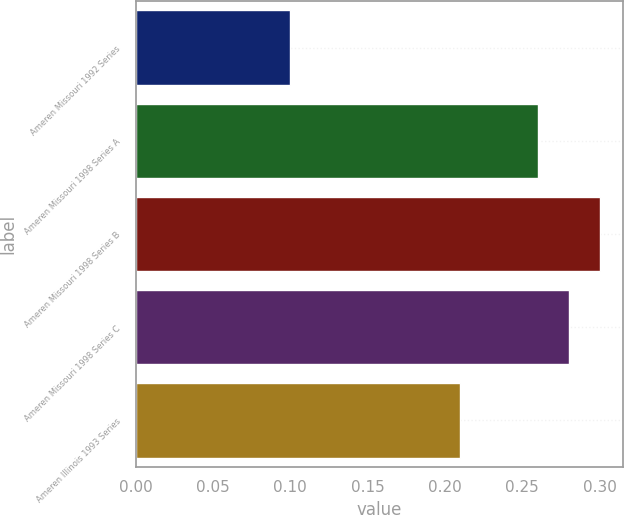Convert chart. <chart><loc_0><loc_0><loc_500><loc_500><bar_chart><fcel>Ameren Missouri 1992 Series<fcel>Ameren Missouri 1998 Series A<fcel>Ameren Missouri 1998 Series B<fcel>Ameren Missouri 1998 Series C<fcel>Ameren Illinois 1993 Series<nl><fcel>0.1<fcel>0.26<fcel>0.3<fcel>0.28<fcel>0.21<nl></chart> 